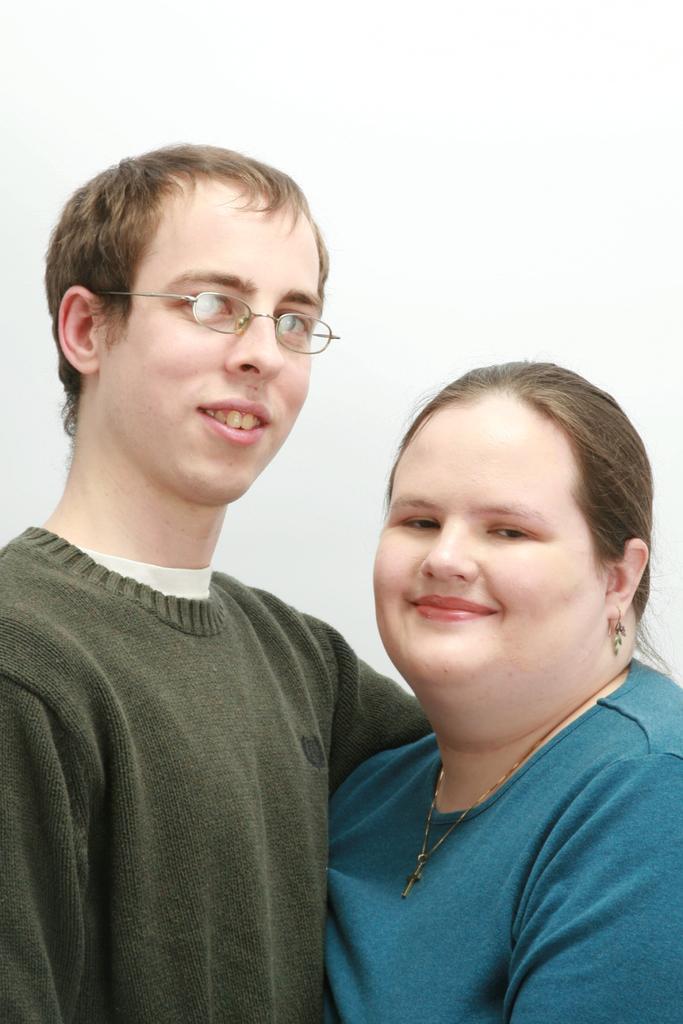Please provide a concise description of this image. In this picture I can see there is a man and a woman standing and smiling. The man is wearing a green color shirt and spectacles and the woman is wearing a blue shirt along with a chain and earrings and the backdrop is white in color. 